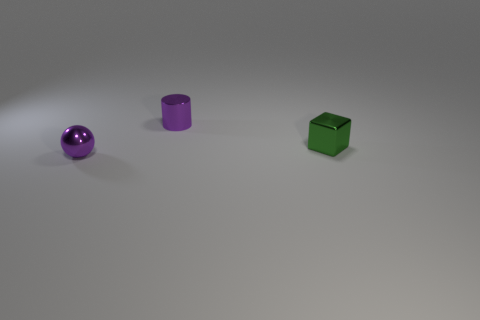There is a metal object that is right of the tiny shiny object that is behind the small shiny object to the right of the purple shiny cylinder; what size is it?
Offer a very short reply. Small. There is a purple thing that is behind the small green metallic thing; what size is it?
Your response must be concise. Small. What shape is the green thing that is made of the same material as the cylinder?
Your answer should be very brief. Cube. Is the purple object that is behind the tiny shiny ball made of the same material as the green block?
Provide a succinct answer. Yes. How many things are either things that are to the right of the small purple metallic sphere or small purple shiny objects behind the sphere?
Your answer should be very brief. 2. There is a metallic object that is behind the green thing; is it the same shape as the purple shiny object in front of the block?
Your answer should be very brief. No. What shape is the green object that is the same size as the sphere?
Provide a short and direct response. Cube. How many shiny objects are either purple things or blocks?
Offer a terse response. 3. Are the tiny purple object that is in front of the green shiny cube and the tiny object right of the small metallic cylinder made of the same material?
Offer a terse response. Yes. There is a cube that is the same material as the cylinder; what color is it?
Ensure brevity in your answer.  Green. 